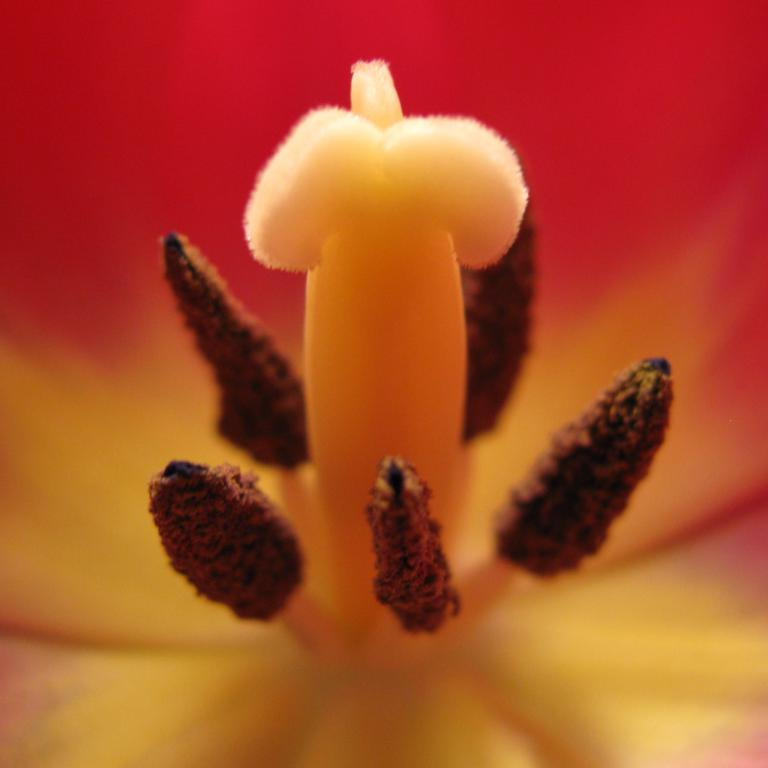What is the main subject of the image? There is a flower in the image. How is the flower presented in the image? The flower is the subject of a macro photograph. What colors can be seen on the flower? The flower has brown and yellow colors. What color is the background of the image? The background of the image is red. How many years of experience does the flower have in the image? The concept of years of experience does not apply to a flower, as it is a living organism and not a professional. 